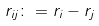Convert formula to latex. <formula><loc_0><loc_0><loc_500><loc_500>r _ { i j } \colon = r _ { i } - r _ { j }</formula> 